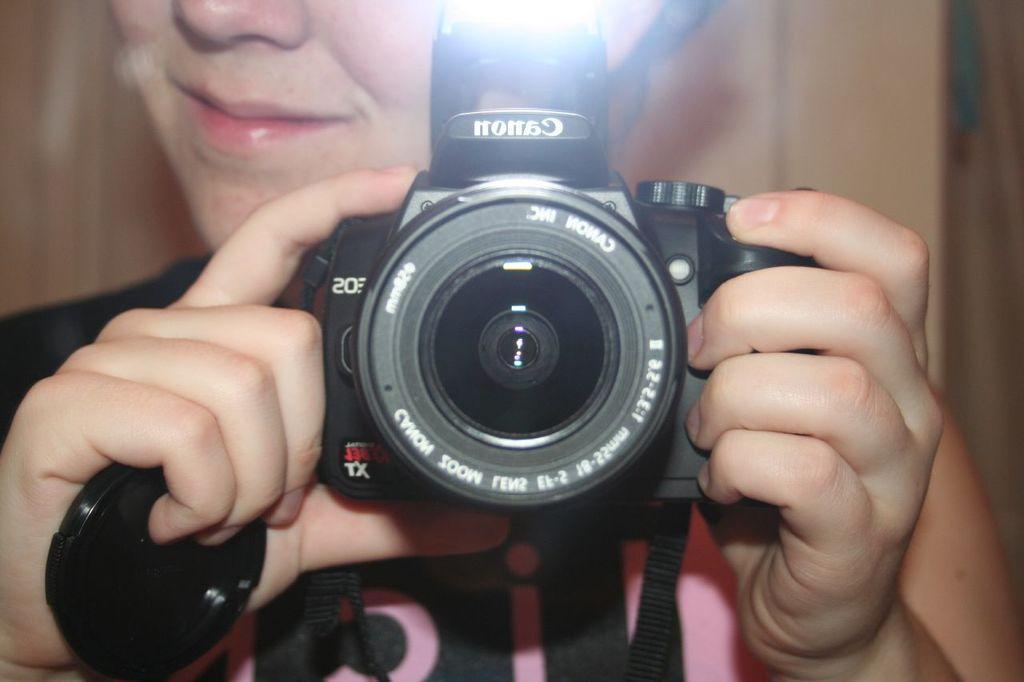Please provide a concise description of this image. In the center of the image there is a person holding a camera in his hand. 